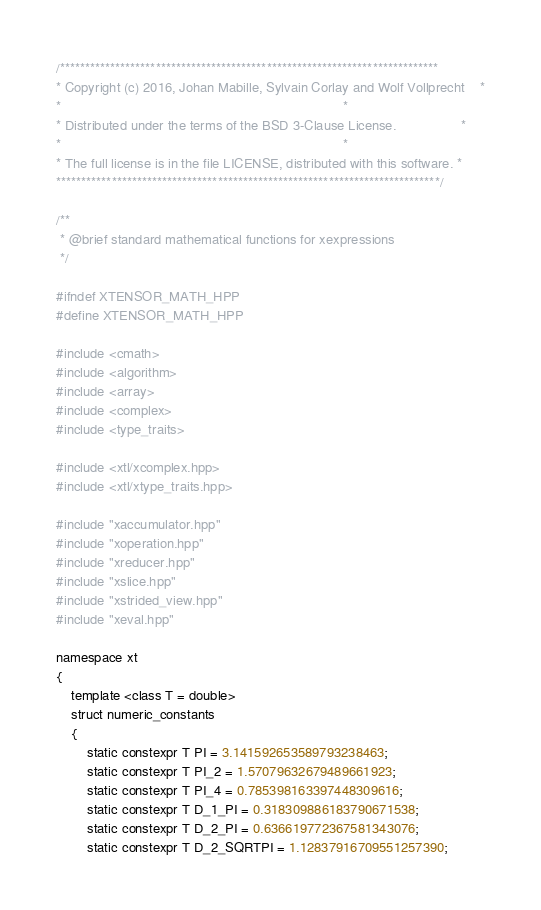Convert code to text. <code><loc_0><loc_0><loc_500><loc_500><_C++_>/***************************************************************************
* Copyright (c) 2016, Johan Mabille, Sylvain Corlay and Wolf Vollprecht    *
*                                                                          *
* Distributed under the terms of the BSD 3-Clause License.                 *
*                                                                          *
* The full license is in the file LICENSE, distributed with this software. *
****************************************************************************/

/**
 * @brief standard mathematical functions for xexpressions
 */

#ifndef XTENSOR_MATH_HPP
#define XTENSOR_MATH_HPP

#include <cmath>
#include <algorithm>
#include <array>
#include <complex>
#include <type_traits>

#include <xtl/xcomplex.hpp>
#include <xtl/xtype_traits.hpp>

#include "xaccumulator.hpp"
#include "xoperation.hpp"
#include "xreducer.hpp"
#include "xslice.hpp"
#include "xstrided_view.hpp"
#include "xeval.hpp"

namespace xt
{
    template <class T = double>
    struct numeric_constants
    {
        static constexpr T PI = 3.141592653589793238463;
        static constexpr T PI_2 = 1.57079632679489661923;
        static constexpr T PI_4 = 0.785398163397448309616;
        static constexpr T D_1_PI = 0.318309886183790671538;
        static constexpr T D_2_PI = 0.636619772367581343076;
        static constexpr T D_2_SQRTPI = 1.12837916709551257390;</code> 